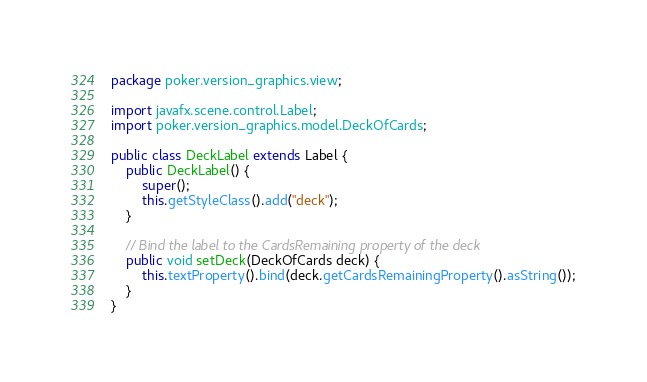<code> <loc_0><loc_0><loc_500><loc_500><_Java_>package poker.version_graphics.view;

import javafx.scene.control.Label;
import poker.version_graphics.model.DeckOfCards;

public class DeckLabel extends Label {
	public DeckLabel() {
		super();
		this.getStyleClass().add("deck");
	}
	
	// Bind the label to the CardsRemaining property of the deck
	public void setDeck(DeckOfCards deck) {
		this.textProperty().bind(deck.getCardsRemainingProperty().asString());
	}
}
</code> 